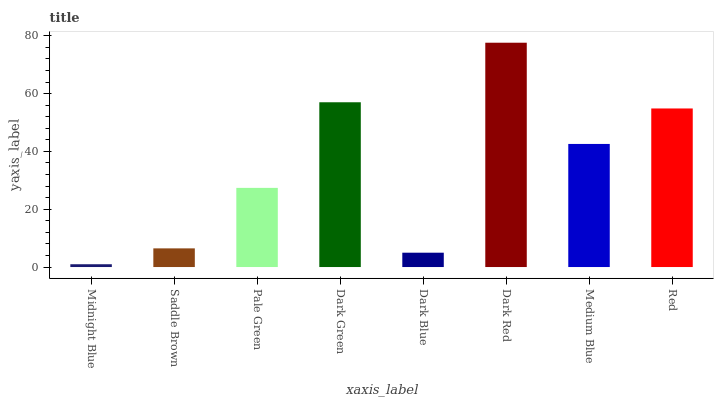Is Midnight Blue the minimum?
Answer yes or no. Yes. Is Dark Red the maximum?
Answer yes or no. Yes. Is Saddle Brown the minimum?
Answer yes or no. No. Is Saddle Brown the maximum?
Answer yes or no. No. Is Saddle Brown greater than Midnight Blue?
Answer yes or no. Yes. Is Midnight Blue less than Saddle Brown?
Answer yes or no. Yes. Is Midnight Blue greater than Saddle Brown?
Answer yes or no. No. Is Saddle Brown less than Midnight Blue?
Answer yes or no. No. Is Medium Blue the high median?
Answer yes or no. Yes. Is Pale Green the low median?
Answer yes or no. Yes. Is Red the high median?
Answer yes or no. No. Is Midnight Blue the low median?
Answer yes or no. No. 